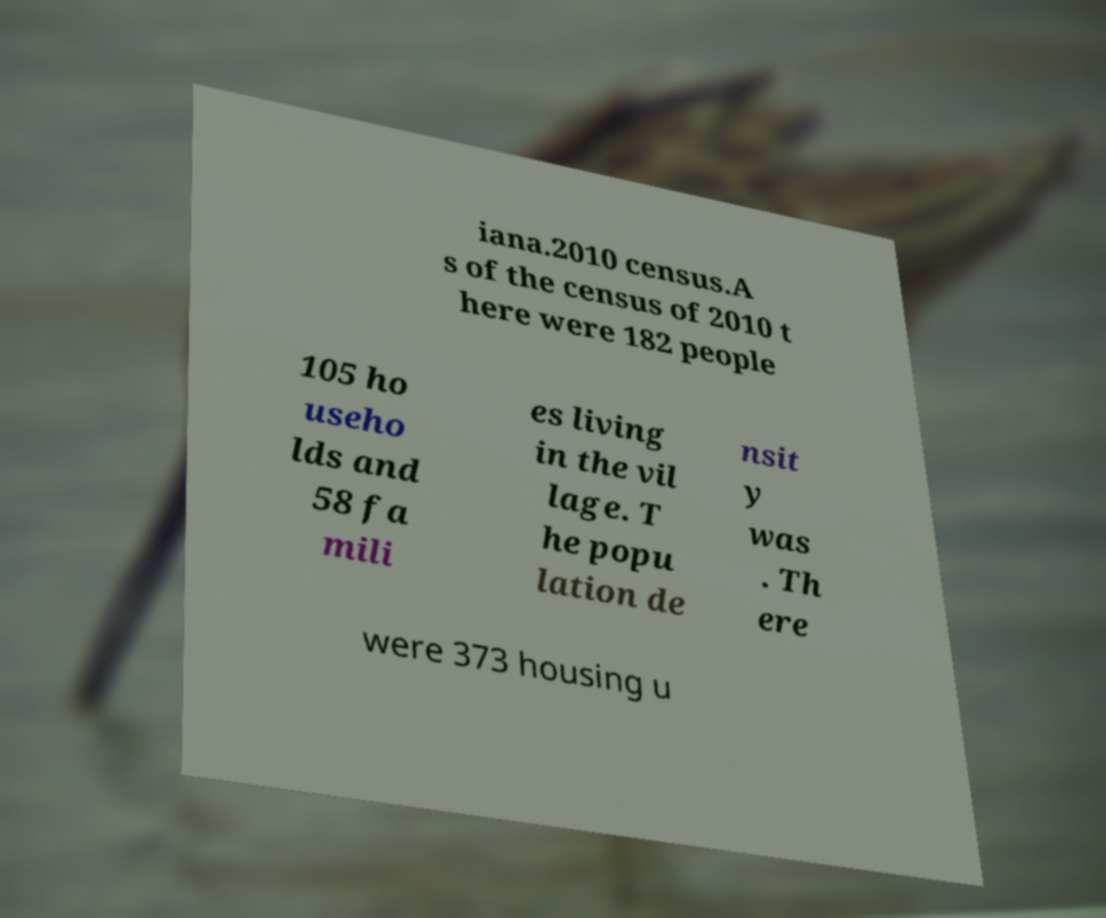Please read and relay the text visible in this image. What does it say? iana.2010 census.A s of the census of 2010 t here were 182 people 105 ho useho lds and 58 fa mili es living in the vil lage. T he popu lation de nsit y was . Th ere were 373 housing u 